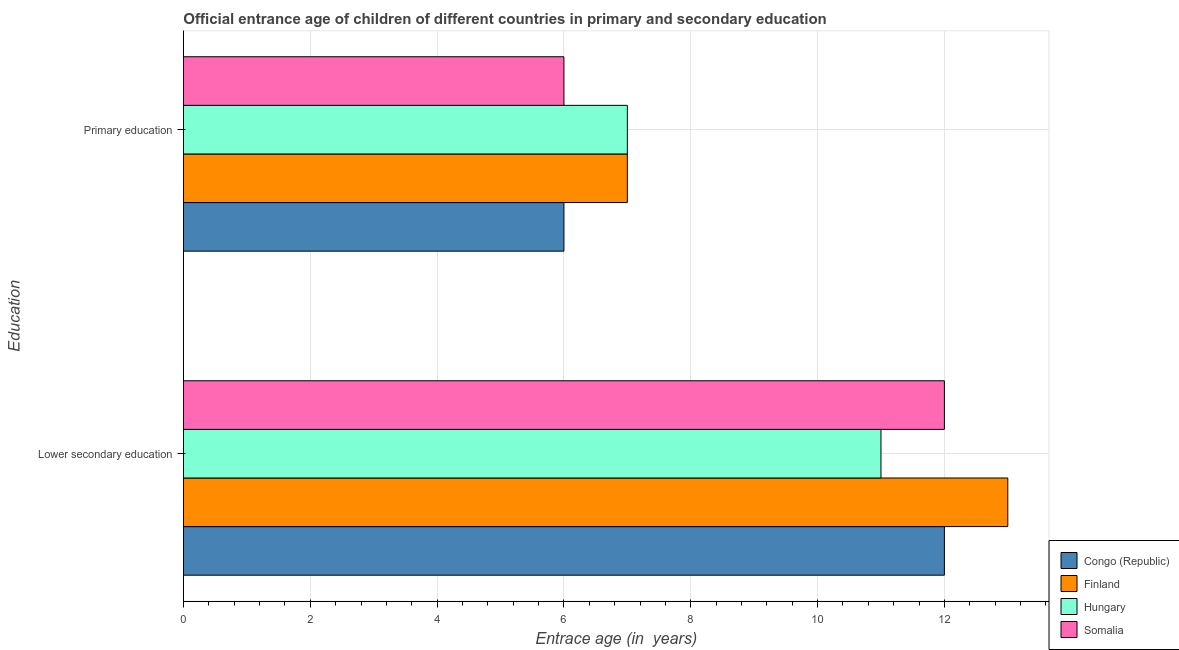How many groups of bars are there?
Make the answer very short. 2. Are the number of bars per tick equal to the number of legend labels?
Your answer should be very brief. Yes. Are the number of bars on each tick of the Y-axis equal?
Your answer should be compact. Yes. What is the label of the 2nd group of bars from the top?
Your response must be concise. Lower secondary education. What is the entrance age of children in lower secondary education in Somalia?
Keep it short and to the point. 12. Across all countries, what is the maximum entrance age of children in lower secondary education?
Offer a very short reply. 13. Across all countries, what is the minimum entrance age of children in lower secondary education?
Ensure brevity in your answer.  11. In which country was the entrance age of children in lower secondary education maximum?
Your answer should be very brief. Finland. In which country was the entrance age of children in lower secondary education minimum?
Your answer should be very brief. Hungary. What is the total entrance age of children in lower secondary education in the graph?
Give a very brief answer. 48. What is the difference between the entrance age of children in lower secondary education in Finland and that in Congo (Republic)?
Provide a succinct answer. 1. What is the difference between the entrance age of chiildren in primary education in Finland and the entrance age of children in lower secondary education in Somalia?
Your answer should be very brief. -5. What is the average entrance age of chiildren in primary education per country?
Give a very brief answer. 6.5. What is the difference between the entrance age of chiildren in primary education and entrance age of children in lower secondary education in Hungary?
Provide a short and direct response. -4. In how many countries, is the entrance age of children in lower secondary education greater than 9.6 years?
Provide a short and direct response. 4. What is the ratio of the entrance age of chiildren in primary education in Congo (Republic) to that in Hungary?
Your answer should be very brief. 0.86. In how many countries, is the entrance age of children in lower secondary education greater than the average entrance age of children in lower secondary education taken over all countries?
Provide a succinct answer. 1. What does the 1st bar from the top in Lower secondary education represents?
Your answer should be very brief. Somalia. What does the 3rd bar from the bottom in Primary education represents?
Your response must be concise. Hungary. How many bars are there?
Your response must be concise. 8. Are all the bars in the graph horizontal?
Your response must be concise. Yes. Are the values on the major ticks of X-axis written in scientific E-notation?
Offer a very short reply. No. Does the graph contain grids?
Your answer should be compact. Yes. Where does the legend appear in the graph?
Keep it short and to the point. Bottom right. What is the title of the graph?
Keep it short and to the point. Official entrance age of children of different countries in primary and secondary education. What is the label or title of the X-axis?
Give a very brief answer. Entrace age (in  years). What is the label or title of the Y-axis?
Provide a succinct answer. Education. What is the Entrace age (in  years) in Hungary in Lower secondary education?
Provide a short and direct response. 11. What is the Entrace age (in  years) of Congo (Republic) in Primary education?
Give a very brief answer. 6. What is the Entrace age (in  years) of Finland in Primary education?
Ensure brevity in your answer.  7. What is the Entrace age (in  years) in Hungary in Primary education?
Your answer should be compact. 7. Across all Education, what is the minimum Entrace age (in  years) in Hungary?
Offer a terse response. 7. What is the total Entrace age (in  years) in Finland in the graph?
Offer a very short reply. 20. What is the difference between the Entrace age (in  years) in Finland in Lower secondary education and that in Primary education?
Make the answer very short. 6. What is the difference between the Entrace age (in  years) of Hungary in Lower secondary education and that in Primary education?
Ensure brevity in your answer.  4. What is the difference between the Entrace age (in  years) in Congo (Republic) in Lower secondary education and the Entrace age (in  years) in Hungary in Primary education?
Keep it short and to the point. 5. What is the difference between the Entrace age (in  years) of Congo (Republic) in Lower secondary education and the Entrace age (in  years) of Somalia in Primary education?
Make the answer very short. 6. What is the difference between the Entrace age (in  years) in Finland in Lower secondary education and the Entrace age (in  years) in Hungary in Primary education?
Keep it short and to the point. 6. What is the difference between the Entrace age (in  years) of Finland in Lower secondary education and the Entrace age (in  years) of Somalia in Primary education?
Keep it short and to the point. 7. What is the average Entrace age (in  years) of Congo (Republic) per Education?
Keep it short and to the point. 9. What is the difference between the Entrace age (in  years) of Congo (Republic) and Entrace age (in  years) of Finland in Lower secondary education?
Offer a very short reply. -1. What is the difference between the Entrace age (in  years) in Congo (Republic) and Entrace age (in  years) in Hungary in Lower secondary education?
Your answer should be very brief. 1. What is the difference between the Entrace age (in  years) in Finland and Entrace age (in  years) in Hungary in Lower secondary education?
Provide a succinct answer. 2. What is the difference between the Entrace age (in  years) in Finland and Entrace age (in  years) in Somalia in Lower secondary education?
Your answer should be compact. 1. What is the difference between the Entrace age (in  years) of Hungary and Entrace age (in  years) of Somalia in Lower secondary education?
Your answer should be very brief. -1. What is the difference between the Entrace age (in  years) in Congo (Republic) and Entrace age (in  years) in Finland in Primary education?
Make the answer very short. -1. What is the difference between the Entrace age (in  years) of Congo (Republic) and Entrace age (in  years) of Somalia in Primary education?
Offer a very short reply. 0. What is the difference between the Entrace age (in  years) in Finland and Entrace age (in  years) in Hungary in Primary education?
Make the answer very short. 0. What is the difference between the Entrace age (in  years) in Finland and Entrace age (in  years) in Somalia in Primary education?
Your answer should be compact. 1. What is the ratio of the Entrace age (in  years) in Congo (Republic) in Lower secondary education to that in Primary education?
Keep it short and to the point. 2. What is the ratio of the Entrace age (in  years) in Finland in Lower secondary education to that in Primary education?
Provide a succinct answer. 1.86. What is the ratio of the Entrace age (in  years) in Hungary in Lower secondary education to that in Primary education?
Keep it short and to the point. 1.57. What is the ratio of the Entrace age (in  years) in Somalia in Lower secondary education to that in Primary education?
Offer a very short reply. 2. What is the difference between the highest and the second highest Entrace age (in  years) in Finland?
Your answer should be compact. 6. What is the difference between the highest and the lowest Entrace age (in  years) of Hungary?
Ensure brevity in your answer.  4. What is the difference between the highest and the lowest Entrace age (in  years) of Somalia?
Your answer should be very brief. 6. 